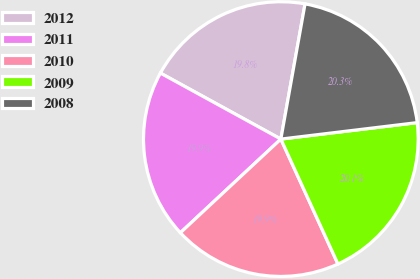Convert chart. <chart><loc_0><loc_0><loc_500><loc_500><pie_chart><fcel>2012<fcel>2011<fcel>2010<fcel>2009<fcel>2008<nl><fcel>19.84%<fcel>19.92%<fcel>19.88%<fcel>20.09%<fcel>20.27%<nl></chart> 